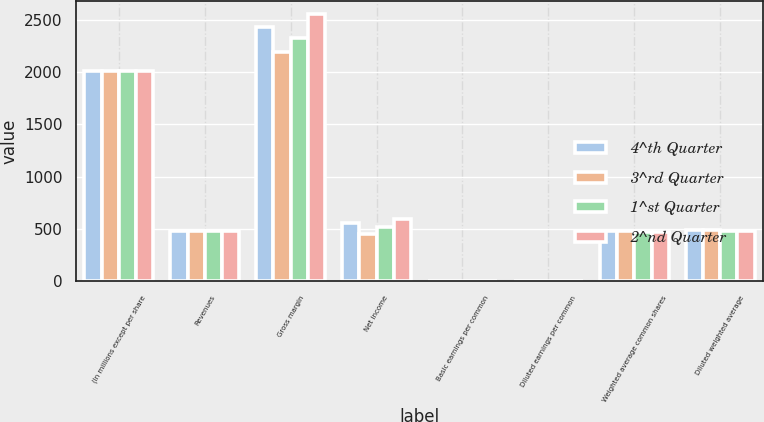Convert chart to OTSL. <chart><loc_0><loc_0><loc_500><loc_500><stacked_bar_chart><ecel><fcel>(In millions except per share<fcel>Revenues<fcel>Gross margin<fcel>Net income<fcel>Basic earnings per common<fcel>Diluted earnings per common<fcel>Weighted average common shares<fcel>Diluted weighted average<nl><fcel>4^th Quarter<fcel>2011<fcel>482.55<fcel>2434<fcel>559<fcel>1.17<fcel>1.14<fcel>479.6<fcel>488.6<nl><fcel>3^rd Quarter<fcel>2011<fcel>482.55<fcel>2193<fcel>457<fcel>0.96<fcel>0.94<fcel>477.9<fcel>487.6<nl><fcel>1^st Quarter<fcel>2011<fcel>482.55<fcel>2327<fcel>523<fcel>1.1<fcel>1.08<fcel>475.3<fcel>485.5<nl><fcel>2^nd Quarter<fcel>2011<fcel>482.55<fcel>2554<fcel>594<fcel>1.27<fcel>1.24<fcel>469.3<fcel>478.7<nl></chart> 